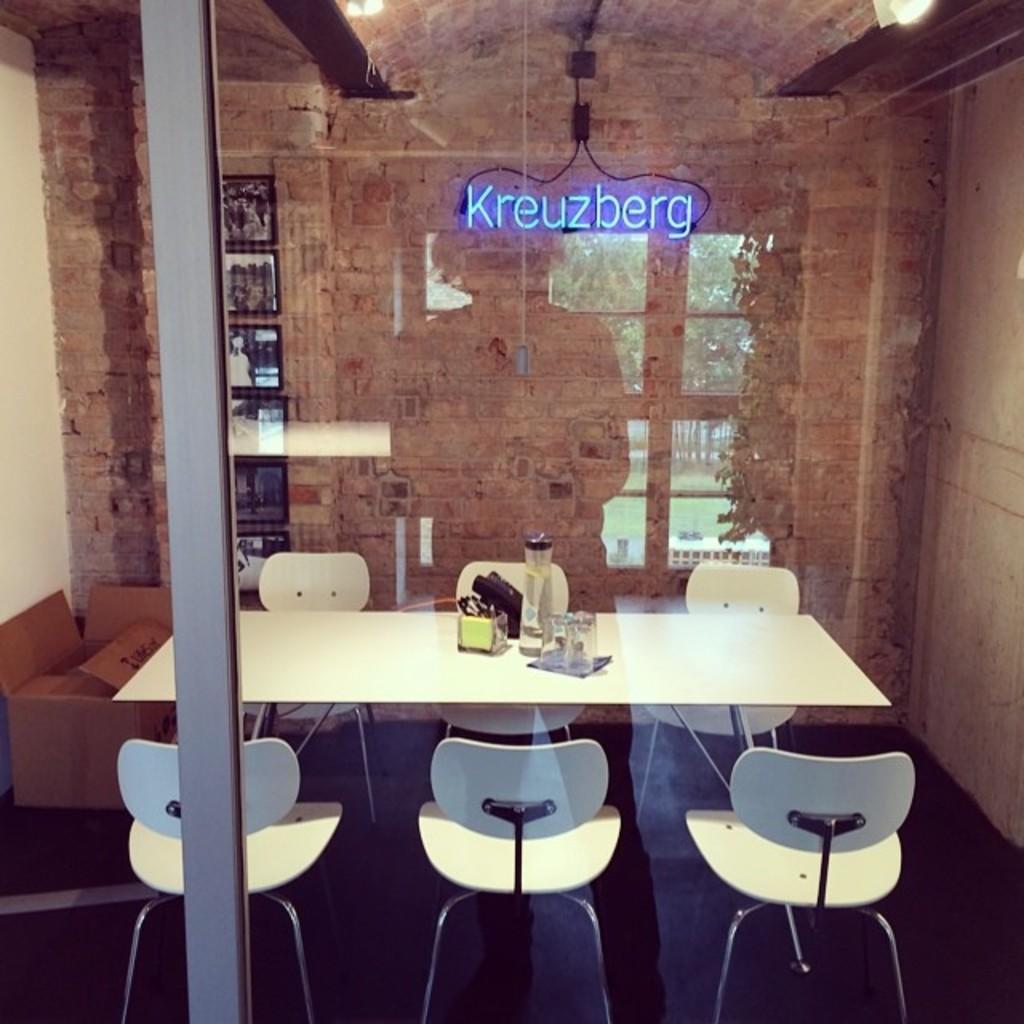Describe this image in one or two sentences. In this image there are chairs and a table, on top of the table there are some objects,behind the table there is a wall with a name, in front of the table there is a glass door. 